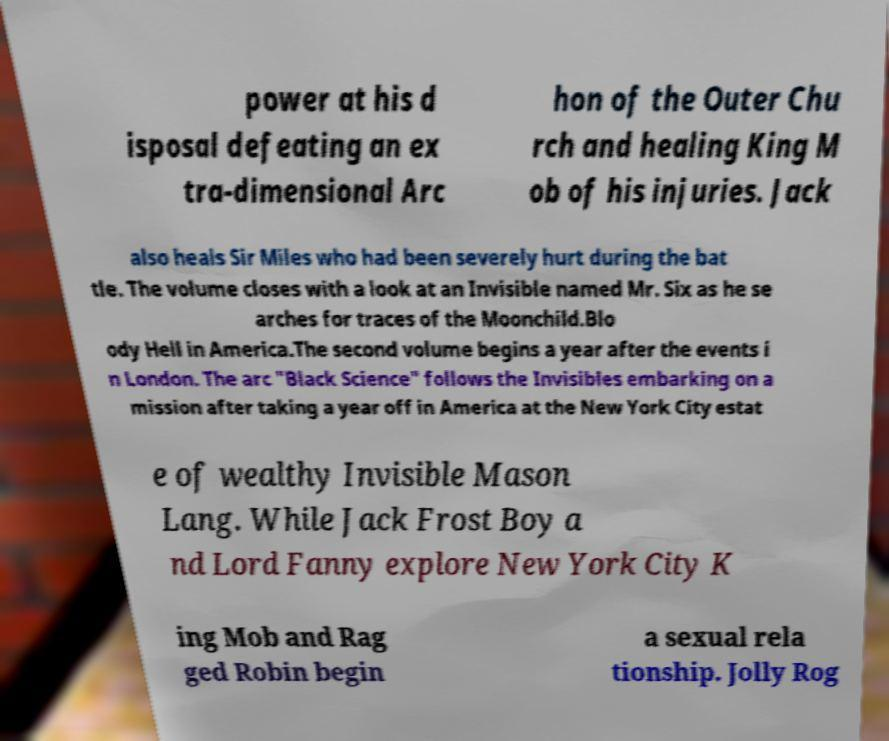Can you accurately transcribe the text from the provided image for me? power at his d isposal defeating an ex tra-dimensional Arc hon of the Outer Chu rch and healing King M ob of his injuries. Jack also heals Sir Miles who had been severely hurt during the bat tle. The volume closes with a look at an Invisible named Mr. Six as he se arches for traces of the Moonchild.Blo ody Hell in America.The second volume begins a year after the events i n London. The arc "Black Science" follows the Invisibles embarking on a mission after taking a year off in America at the New York City estat e of wealthy Invisible Mason Lang. While Jack Frost Boy a nd Lord Fanny explore New York City K ing Mob and Rag ged Robin begin a sexual rela tionship. Jolly Rog 